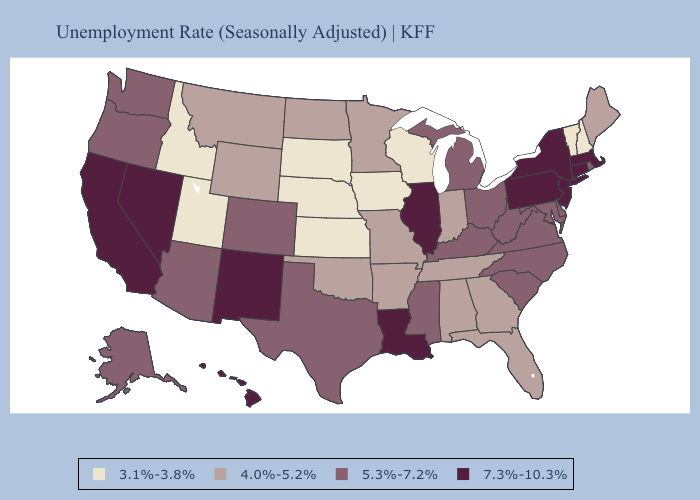What is the value of Georgia?
Keep it brief. 4.0%-5.2%. What is the highest value in the South ?
Quick response, please. 7.3%-10.3%. What is the lowest value in states that border South Carolina?
Short answer required. 4.0%-5.2%. What is the highest value in the South ?
Quick response, please. 7.3%-10.3%. Among the states that border Colorado , which have the lowest value?
Answer briefly. Kansas, Nebraska, Utah. What is the value of Massachusetts?
Give a very brief answer. 7.3%-10.3%. What is the highest value in the Northeast ?
Be succinct. 7.3%-10.3%. What is the value of Maryland?
Be succinct. 5.3%-7.2%. What is the value of Kansas?
Give a very brief answer. 3.1%-3.8%. Does Nevada have the highest value in the USA?
Give a very brief answer. Yes. What is the value of California?
Give a very brief answer. 7.3%-10.3%. Among the states that border Tennessee , does Virginia have the lowest value?
Write a very short answer. No. Name the states that have a value in the range 3.1%-3.8%?
Keep it brief. Idaho, Iowa, Kansas, Nebraska, New Hampshire, South Dakota, Utah, Vermont, Wisconsin. What is the lowest value in the USA?
Give a very brief answer. 3.1%-3.8%. 